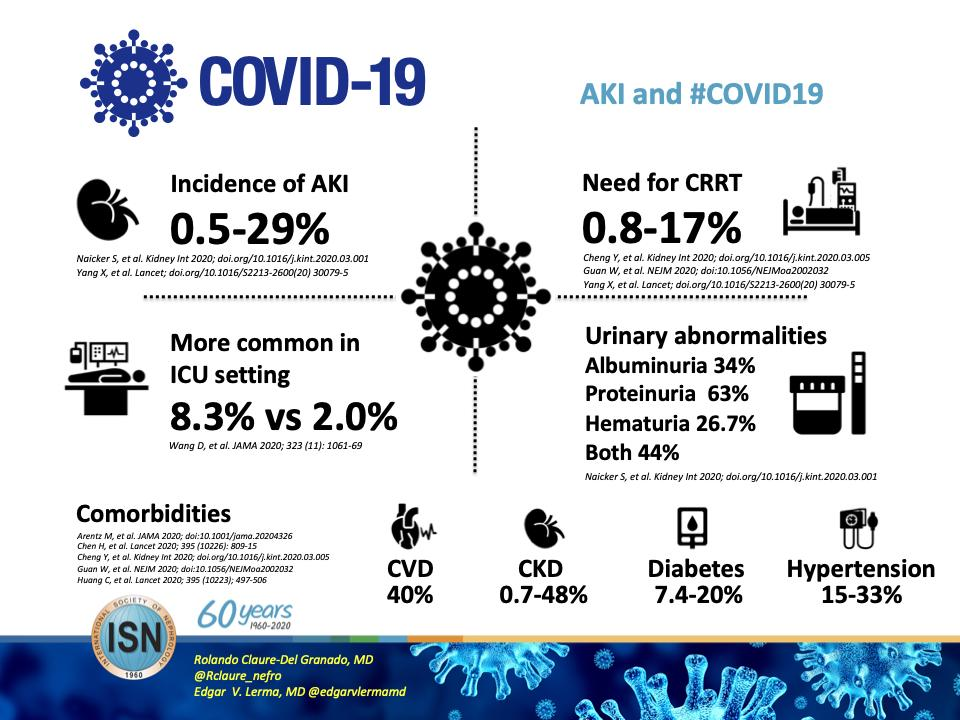Specify some key components in this picture. The incidence of AKI is cited in two journals. Proteinuria is the condition in urinary abnormalities that shows the highest proportion among the given conditions. The need for CRRT is cited in three or two journals, according to the information provided. The journal cited as "Kidney International" in the discussion of urinary abnormalities following COVID-19 infection is named [insert name of journal here]. 